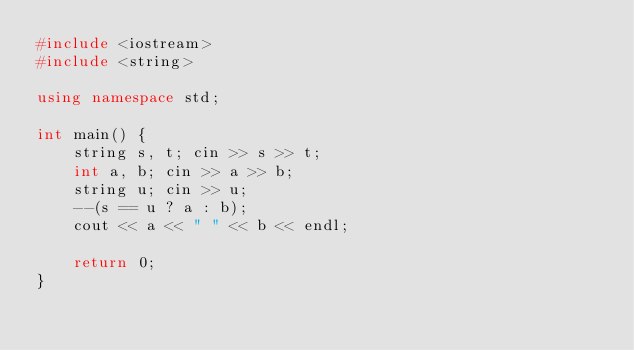Convert code to text. <code><loc_0><loc_0><loc_500><loc_500><_C++_>#include <iostream>
#include <string>

using namespace std;

int main() {
	string s, t; cin >> s >> t;
	int a, b; cin >> a >> b;
	string u; cin >> u;
	--(s == u ? a : b);
	cout << a << " " << b << endl;

	return 0;
}</code> 